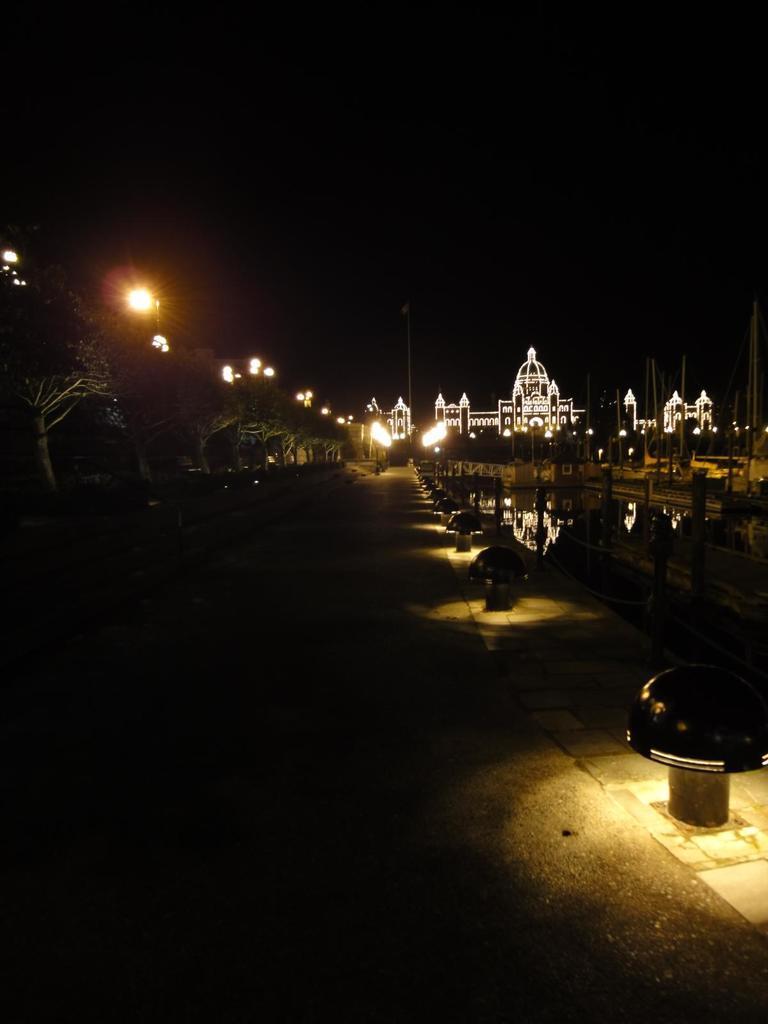Please provide a concise description of this image. Background portion of the picture is completely dark. It seems like a temple and it is decorated with the lights. On the left side of the picture we can see the trees, lights. On the right side of the picture we can see the objects on the road and it seems like a railing. Few poles are visible. 